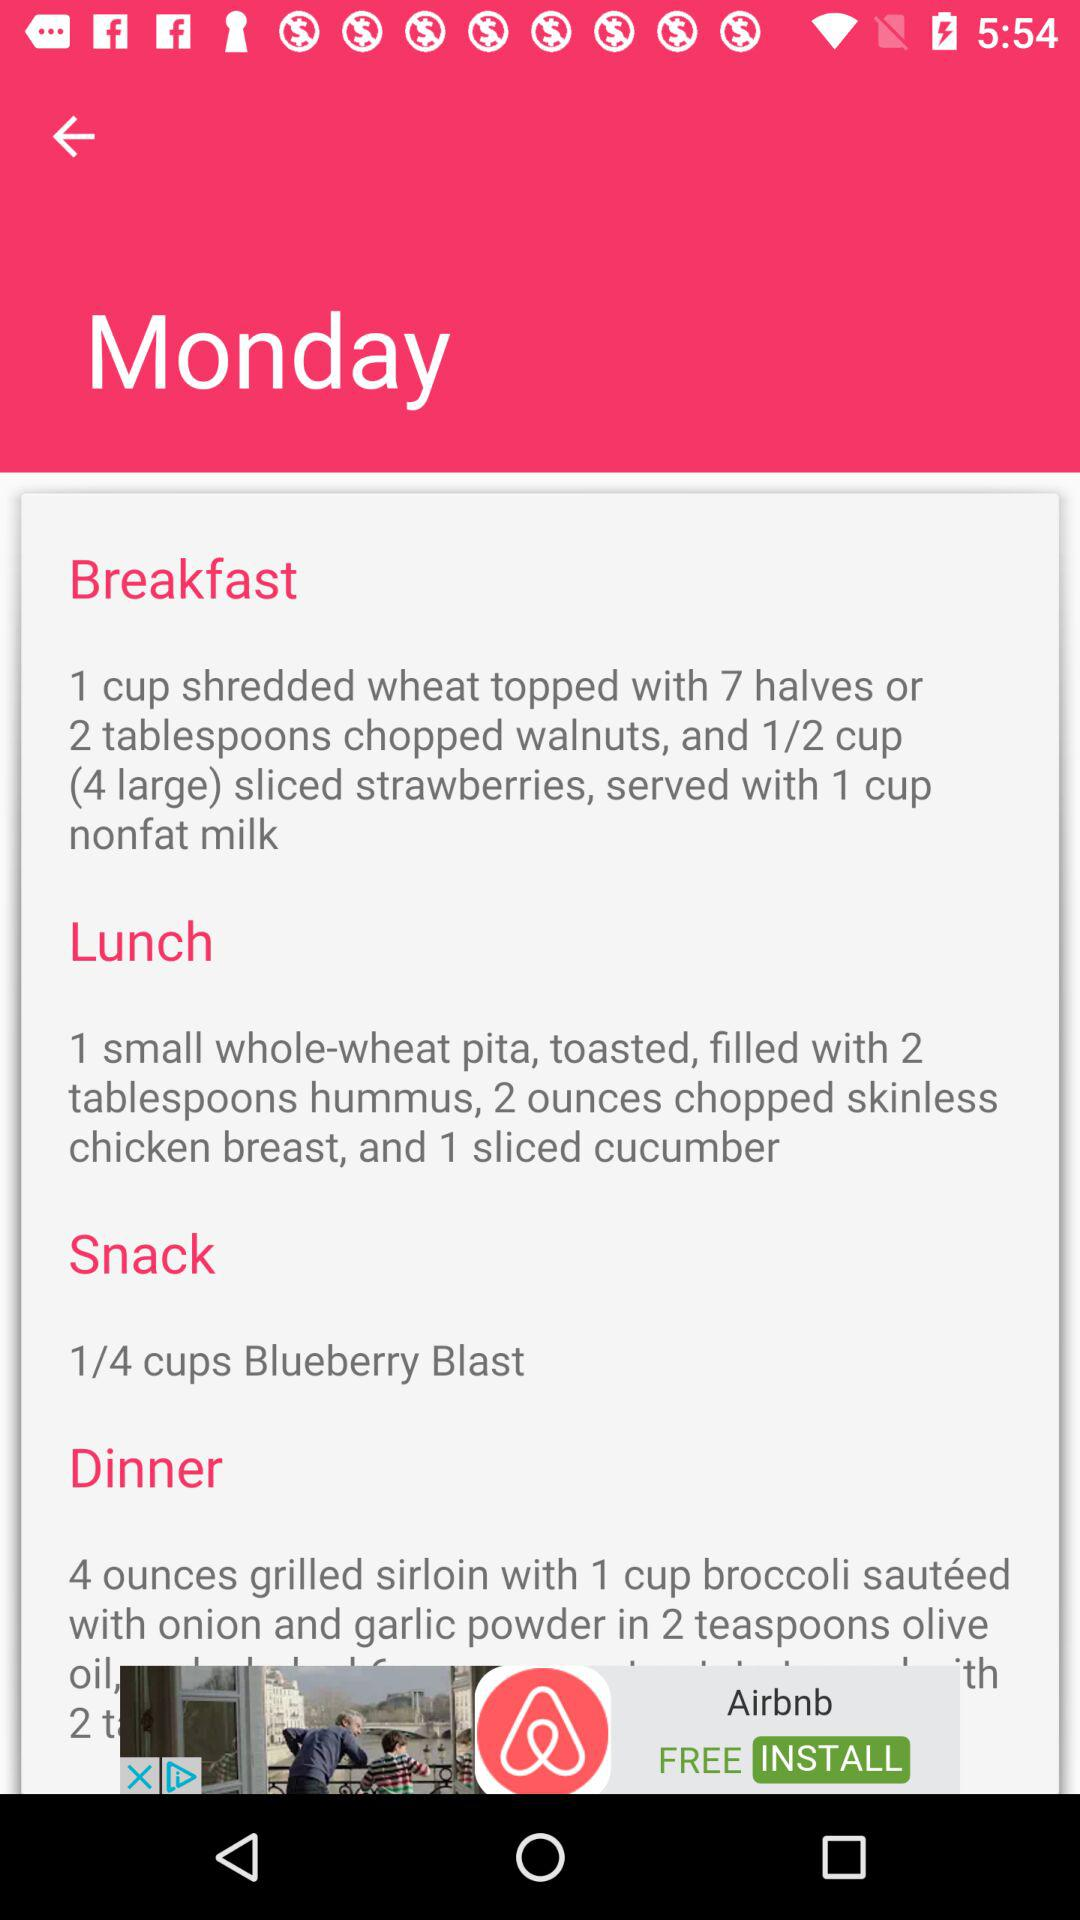How much chopped walnut do we need for breakfast? You need 2 tablespoons of chopped walnuts for breakfast. 